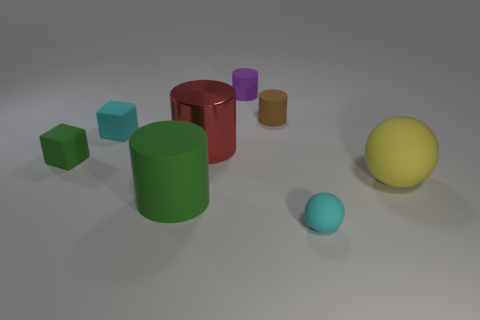How many tiny cyan things have the same shape as the tiny green thing?
Offer a very short reply. 1. What number of green things are either metallic objects or big cylinders?
Make the answer very short. 1. What size is the matte sphere to the right of the cyan object that is right of the metallic cylinder?
Your answer should be very brief. Large. There is another object that is the same shape as the small green matte thing; what is it made of?
Ensure brevity in your answer.  Rubber. What number of other yellow things have the same size as the shiny object?
Offer a very short reply. 1. Is the size of the purple object the same as the metal cylinder?
Ensure brevity in your answer.  No. What size is the object that is on the left side of the big shiny cylinder and in front of the tiny green thing?
Make the answer very short. Large. Are there more big green cylinders in front of the large rubber ball than tiny spheres that are to the left of the brown cylinder?
Provide a succinct answer. Yes. There is a big rubber object that is the same shape as the big metal object; what is its color?
Your answer should be compact. Green. There is a tiny cube to the right of the tiny green cube; is it the same color as the tiny ball?
Your answer should be compact. Yes. 